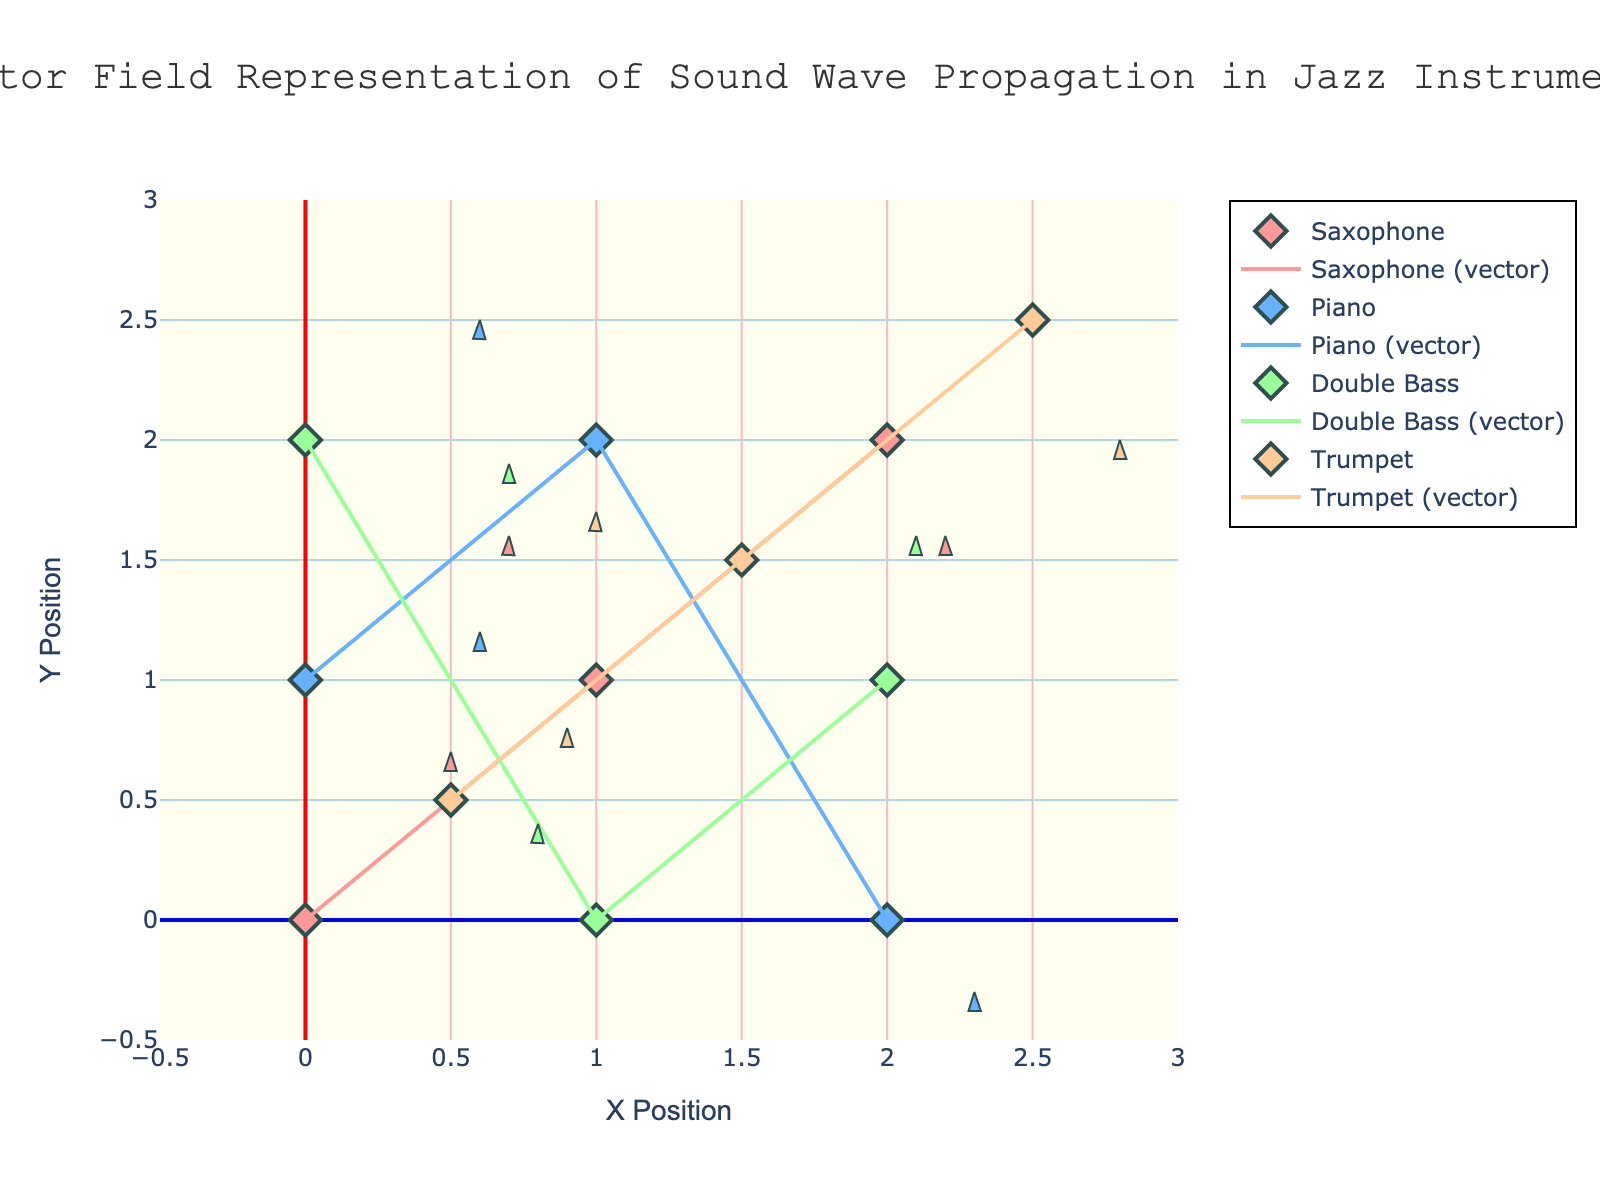What is the title of the figure? The title is located at the top of the figure, centered, and is written in a larger font size compared to other text elements in the figure.
Answer: Vector Field Representation of Sound Wave Propagation in Jazz Instruments How many distinct instruments are depicted in the figure? By looking at the legend on the right side of the figure, we can identify the number of distinct instruments with different symbols and colors.
Answer: 4 Which instrument has the vector located at (0, 2)? Locate the point (0, 2) in the figure. The color and marker shape at this point correspond to an instrument listed in the legend.
Answer: Double Bass What are the color codes used for the instruments? Refer to the legend and observe the colors associated with each instrument. Each instrument is colored differently.
Answer: Saxophone: Red, Piano: Blue, Double Bass: Green, Trumpet: Orange Which instrument has the longest vector in the positive x-direction? Examine the vectors in the figure and look for the longest one pointing right. Note the corresponding instrument.
Answer: Double Bass Compare the vectors of the Saxophone and Trumpet at their respective positions. Which instrument's vector has a greater magnitude? Calculate the magnitude for the vectors of both instruments using the formula √(u² + v²) at their respective positions. Compare the resulting values.
Answer: Magnitude of Trump's vector is greater What are the x and y components of the vector from the Piano positioned at (1, 2)? Locate the position (1, 2) for the Piano in the figure. Identify the x and y components (u, v) of the vector at this location.
Answer: -0.4, 0.5 How do the vectors for the Saxophone at (1,1) and the Piano at (1,2) differ in direction? Determine the direction of both vectors by calculating the angles using atan2(v, u) for each. Compare their directions based on the angles.
Answer: Saxophone angle: approximately 63.4 degrees, Piano angle: approximately 128 degrees What is the total distance covered by the vector of the Double Bass starting from (0, 2)? The vector's distance can be calculated using the formula √(u² + v²) for the vector originating from (0, 2).
Answer: √(0.7² + (-0.1)²) = 0.70 Which instrument's vectors have components with both positive and negative values, showing a bidirectional nature? Review the components (u, v) for all vectors in the figure to identify vectors with both positive and negative values, indicating bidirectional behavior.
Answer: Saxophone, Piano, Double Bass, Trumpet 